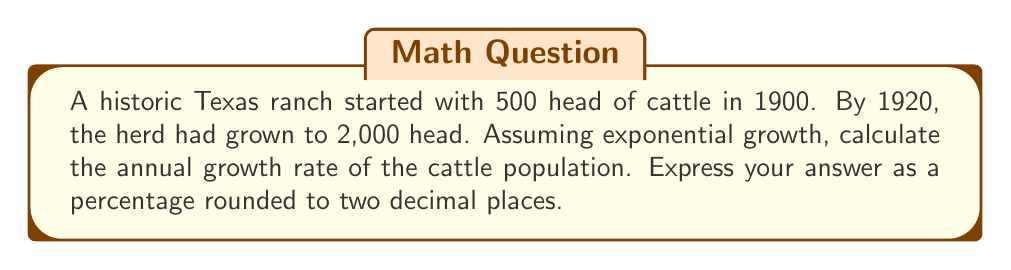What is the answer to this math problem? Let's approach this step-by-step using the exponential growth formula:

1) The exponential growth formula is:
   $$A = P(1 + r)^t$$
   Where:
   $A$ = Final amount
   $P$ = Initial amount
   $r$ = Annual growth rate (in decimal form)
   $t$ = Time in years

2) We know:
   $P = 500$ (initial herd size in 1900)
   $A = 2000$ (final herd size in 1920)
   $t = 20$ years (from 1900 to 1920)

3) Let's plug these into our formula:
   $$2000 = 500(1 + r)^{20}$$

4) Divide both sides by 500:
   $$4 = (1 + r)^{20}$$

5) Take the 20th root of both sides:
   $$\sqrt[20]{4} = 1 + r$$

6) Subtract 1 from both sides:
   $$\sqrt[20]{4} - 1 = r$$

7) Calculate this value:
   $$r \approx 0.0708$$

8) Convert to a percentage by multiplying by 100:
   $$0.0708 \times 100 \approx 7.08\%$$

Therefore, the annual growth rate is approximately 7.08%.
Answer: 7.08% 